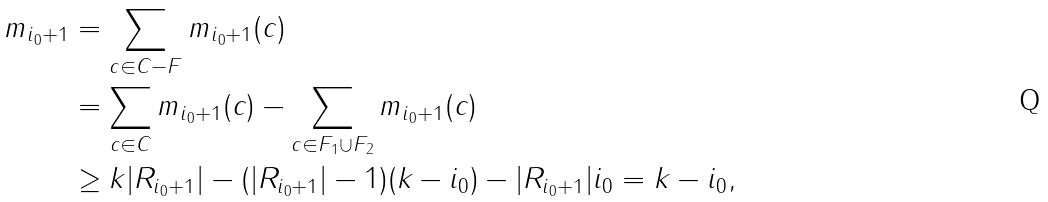<formula> <loc_0><loc_0><loc_500><loc_500>m _ { { i _ { 0 } } + 1 } & = \sum _ { c \in C - F } m _ { i _ { 0 } + 1 } ( c ) \\ & = \sum _ { c \in C } m _ { i _ { 0 } + 1 } ( c ) - \sum _ { c \in F _ { 1 } \cup F _ { 2 } } m _ { i _ { 0 } + 1 } ( c ) \\ & \geq k | R _ { { i _ { 0 } } + 1 } | - ( | R _ { { i _ { 0 } } + 1 } | - 1 ) ( k - { i _ { 0 } } ) - | R _ { { i _ { 0 } } + 1 } | { i _ { 0 } } = k - { i _ { 0 } } ,</formula> 